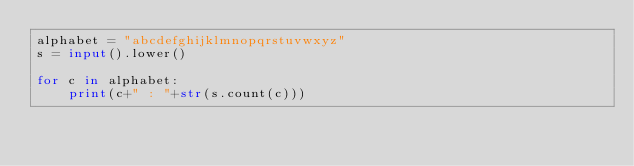Convert code to text. <code><loc_0><loc_0><loc_500><loc_500><_Python_>alphabet = "abcdefghijklmnopqrstuvwxyz"
s = input().lower()

for c in alphabet:
    print(c+" : "+str(s.count(c)))</code> 